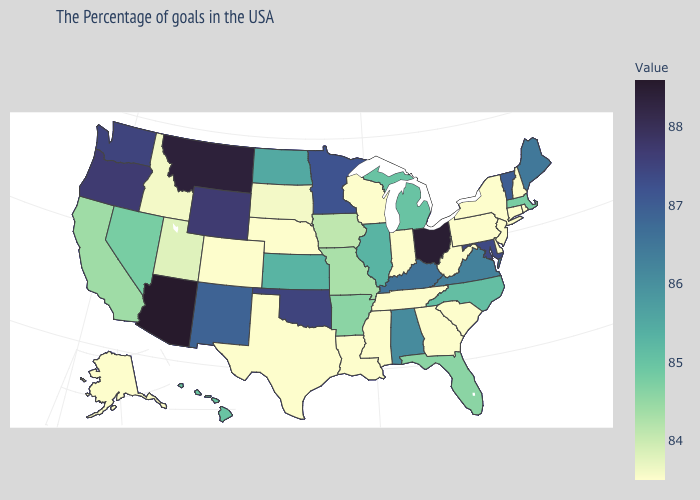Does Alaska have the lowest value in the West?
Write a very short answer. Yes. Which states have the lowest value in the USA?
Keep it brief. Rhode Island, New Hampshire, Connecticut, New York, New Jersey, Delaware, Pennsylvania, South Carolina, West Virginia, Georgia, Indiana, Tennessee, Wisconsin, Mississippi, Louisiana, Nebraska, Texas, Colorado, Alaska. Is the legend a continuous bar?
Be succinct. Yes. Which states hav the highest value in the Northeast?
Write a very short answer. Vermont. Does Indiana have a higher value than Iowa?
Concise answer only. No. Which states have the lowest value in the USA?
Give a very brief answer. Rhode Island, New Hampshire, Connecticut, New York, New Jersey, Delaware, Pennsylvania, South Carolina, West Virginia, Georgia, Indiana, Tennessee, Wisconsin, Mississippi, Louisiana, Nebraska, Texas, Colorado, Alaska. Among the states that border Indiana , does Ohio have the highest value?
Give a very brief answer. Yes. 